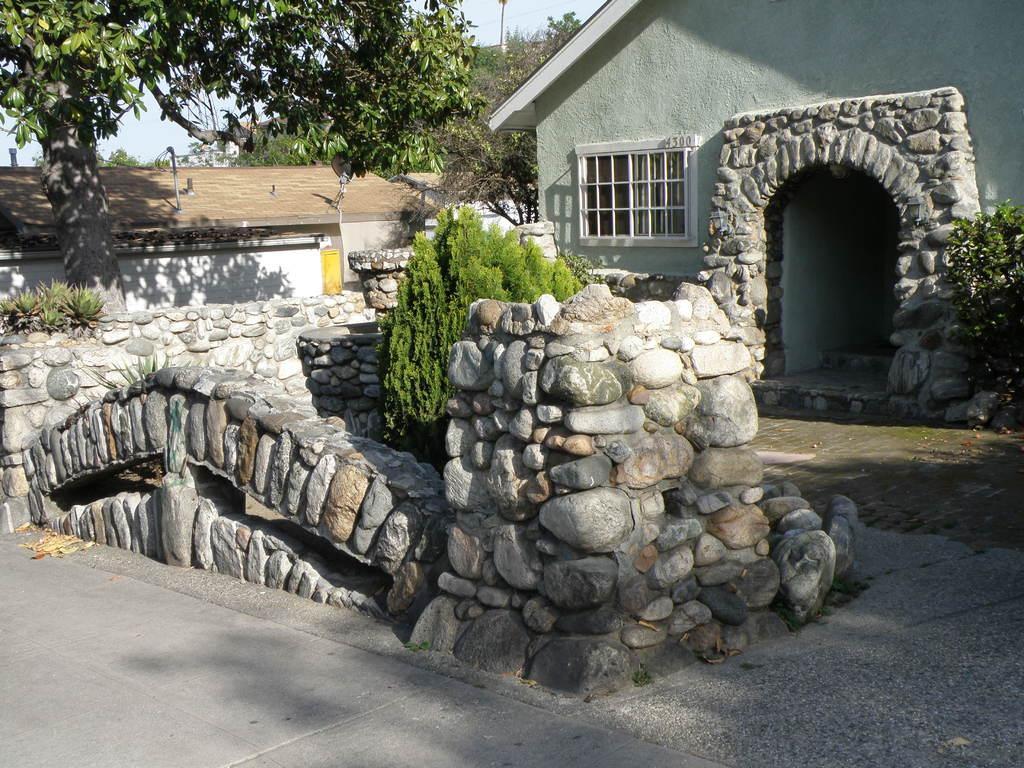Describe this image in one or two sentences. In this picture I can see the buildings, trees and plants. At the bottom I can see the road. At the top I can see the sky. 